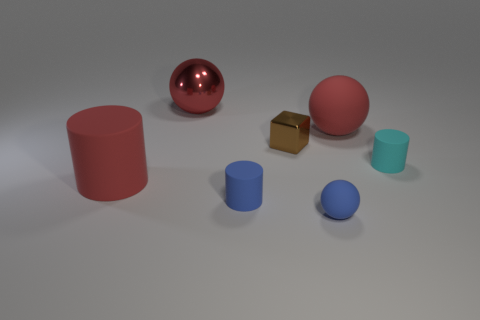There is a small object that is both in front of the brown object and left of the tiny matte sphere; what material is it?
Provide a short and direct response. Rubber. How many tiny blue objects are in front of the red matte sphere?
Provide a short and direct response. 2. Does the small blue thing that is on the left side of the tiny brown block have the same material as the cylinder right of the tiny metallic thing?
Provide a succinct answer. Yes. How many objects are balls on the right side of the small brown cube or small blue balls?
Provide a succinct answer. 2. Are there fewer rubber cylinders behind the tiny cube than matte cylinders to the right of the tiny cyan matte object?
Offer a very short reply. No. What number of other things are there of the same size as the red shiny sphere?
Ensure brevity in your answer.  2. Does the brown cube have the same material as the red thing to the right of the big red shiny ball?
Your response must be concise. No. How many objects are either red things that are in front of the cyan matte thing or metallic objects in front of the big metal ball?
Make the answer very short. 2. The cube is what color?
Your response must be concise. Brown. Are there fewer blue objects behind the big red cylinder than tiny objects?
Make the answer very short. Yes. 